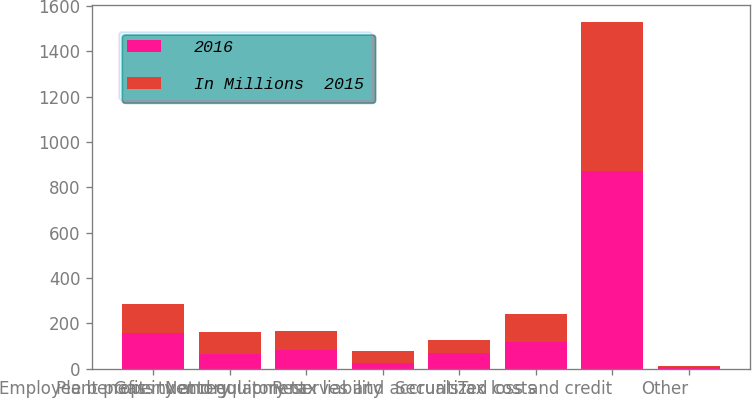Convert chart to OTSL. <chart><loc_0><loc_0><loc_500><loc_500><stacked_bar_chart><ecel><fcel>Employee benefits<fcel>Gas inventory<fcel>Plant property and equipment<fcel>Net regulatory tax liability<fcel>Reserves and accruals<fcel>Securitized costs<fcel>Tax loss and credit<fcel>Other<nl><fcel>2016<fcel>158<fcel>65<fcel>82.5<fcel>27<fcel>69<fcel>118<fcel>871<fcel>6<nl><fcel>In Millions  2015<fcel>127<fcel>96<fcel>82.5<fcel>50<fcel>59<fcel>122<fcel>657<fcel>5<nl></chart> 